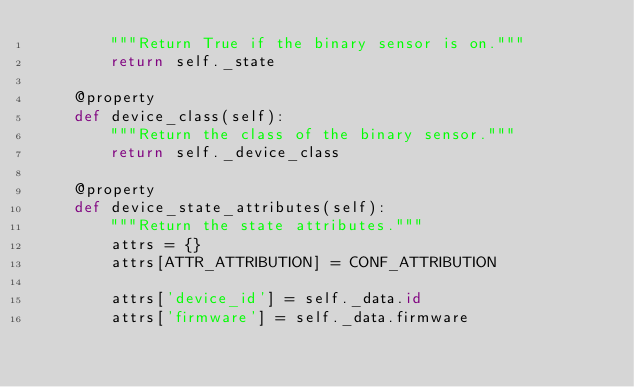Convert code to text. <code><loc_0><loc_0><loc_500><loc_500><_Python_>        """Return True if the binary sensor is on."""
        return self._state

    @property
    def device_class(self):
        """Return the class of the binary sensor."""
        return self._device_class

    @property
    def device_state_attributes(self):
        """Return the state attributes."""
        attrs = {}
        attrs[ATTR_ATTRIBUTION] = CONF_ATTRIBUTION

        attrs['device_id'] = self._data.id
        attrs['firmware'] = self._data.firmware</code> 